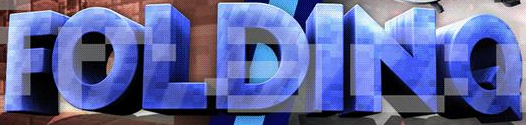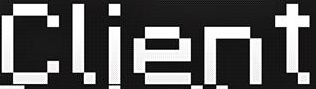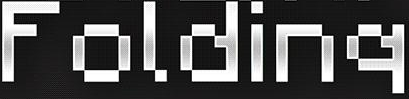What text appears in these images from left to right, separated by a semicolon? FOLDINQ; Client; Folding 